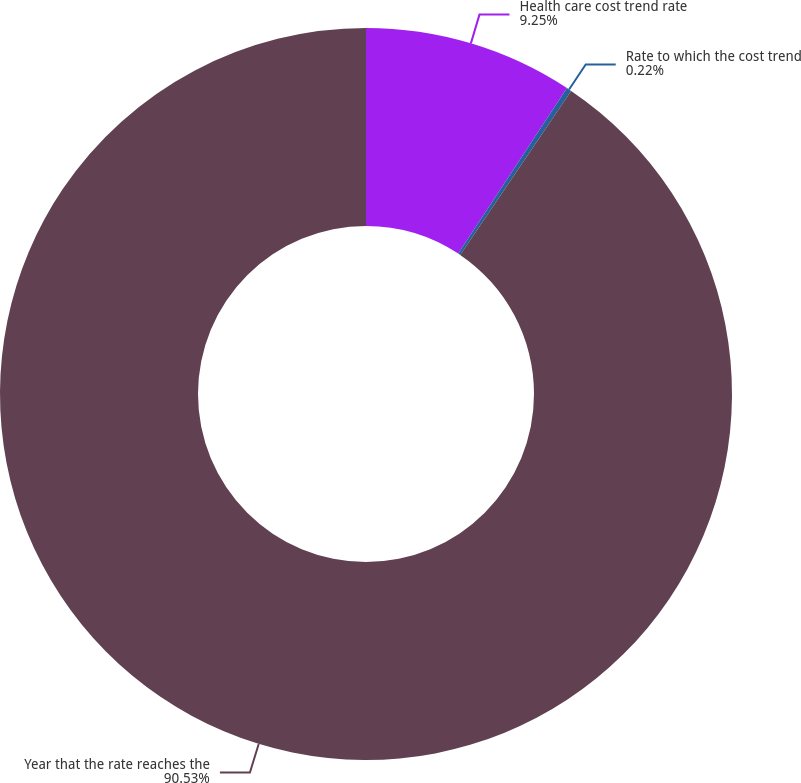Convert chart. <chart><loc_0><loc_0><loc_500><loc_500><pie_chart><fcel>Health care cost trend rate<fcel>Rate to which the cost trend<fcel>Year that the rate reaches the<nl><fcel>9.25%<fcel>0.22%<fcel>90.52%<nl></chart> 